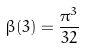Convert formula to latex. <formula><loc_0><loc_0><loc_500><loc_500>\beta ( 3 ) = \frac { \pi ^ { 3 } } { 3 2 }</formula> 